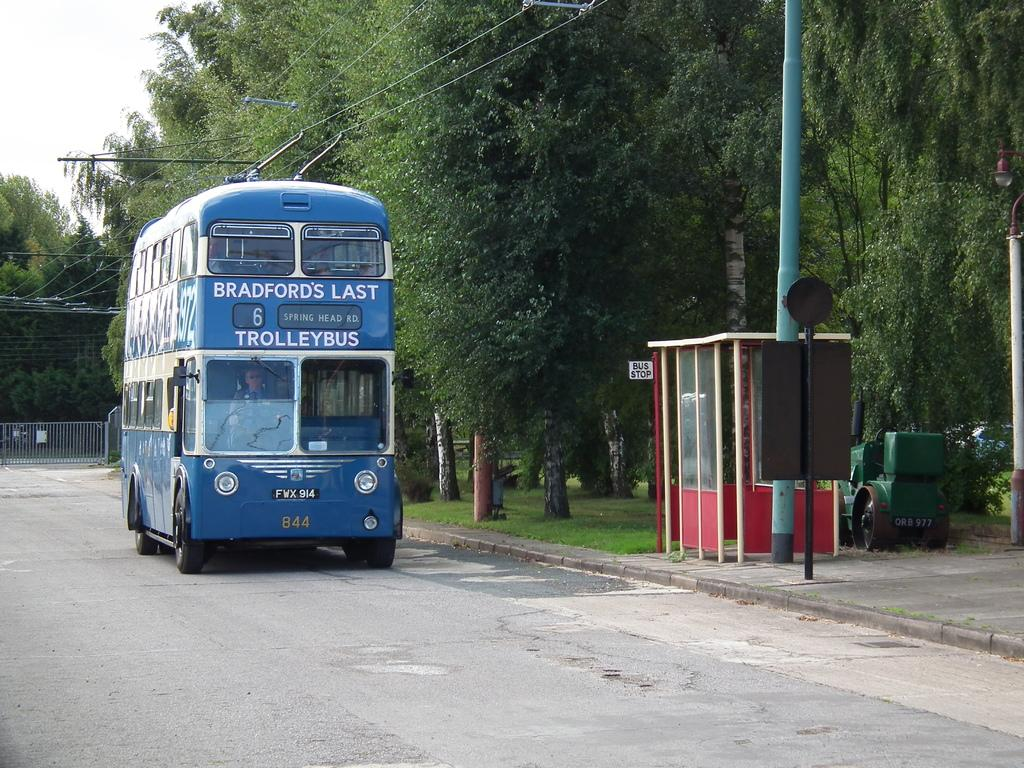<image>
Offer a succinct explanation of the picture presented. A Trollerbus that has the words Bradford's Last labeled on the front of it 